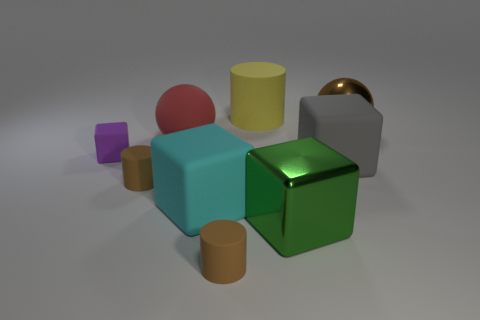Is there any other thing of the same color as the large cylinder?
Your response must be concise. No. What is the material of the gray object that is the same shape as the big green thing?
Keep it short and to the point. Rubber. How many other objects are the same size as the rubber sphere?
Your response must be concise. 5. What is the material of the large gray object?
Offer a terse response. Rubber. Are there more large cyan rubber things right of the gray matte cube than small brown objects?
Provide a short and direct response. No. Is there a brown sphere?
Your answer should be compact. Yes. What number of other things are the same shape as the large yellow rubber object?
Your answer should be compact. 2. Does the ball left of the green metal cube have the same color as the large metal object behind the tiny purple matte thing?
Your answer should be very brief. No. How big is the brown thing that is behind the small brown object that is behind the big metal thing in front of the purple matte block?
Your response must be concise. Large. What shape is the big thing that is in front of the gray cube and to the left of the metallic block?
Provide a short and direct response. Cube. 